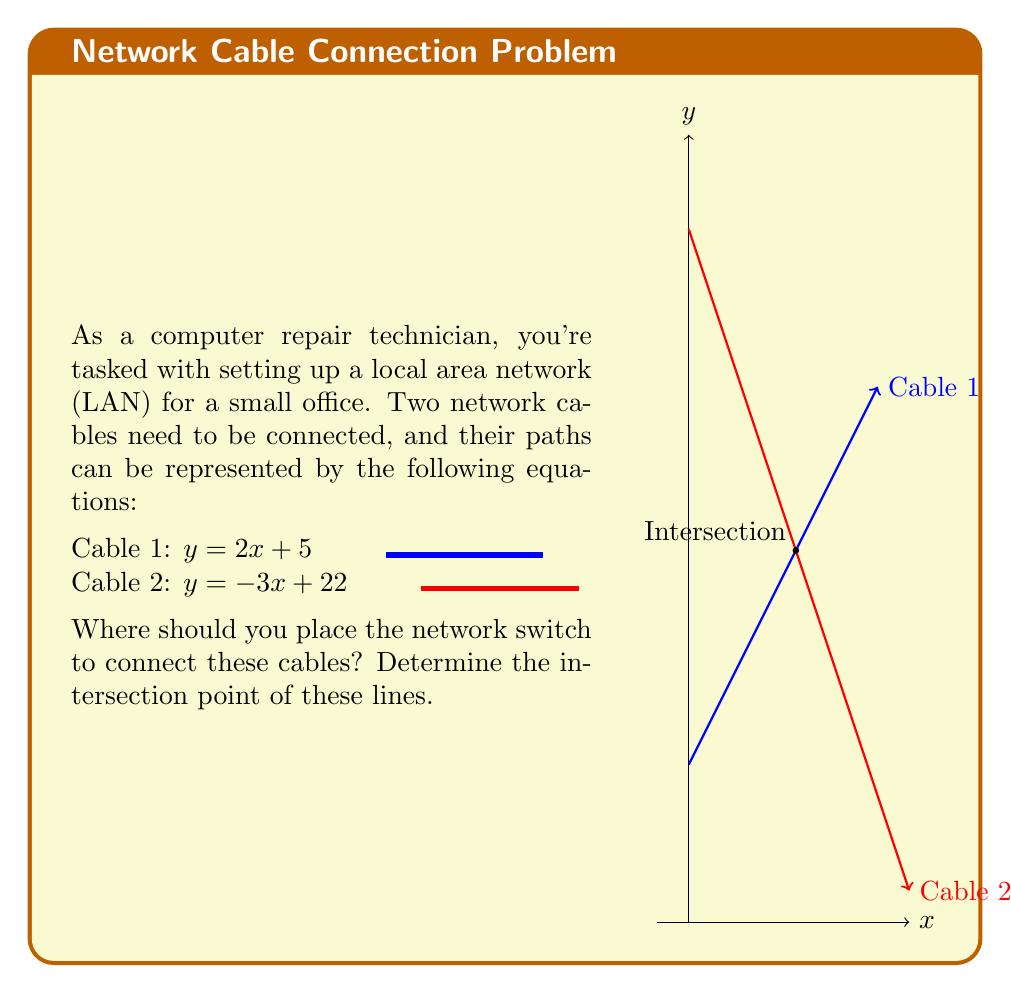Can you solve this math problem? Let's solve this step-by-step:

1) We have two linear equations:
   Cable 1: $y = 2x + 5$
   Cable 2: $y = -3x + 22$

2) At the intersection point, the $x$ and $y$ coordinates will be the same for both equations. So we can set them equal to each other:

   $2x + 5 = -3x + 22$

3) Now, let's solve for $x$:
   $2x + 5 = -3x + 22$
   $2x + 3x = 22 - 5$
   $5x = 17$
   $x = \frac{17}{5} = 3.4$

4) Now that we know $x$, we can substitute it into either of the original equations to find $y$. Let's use Cable 1's equation:

   $y = 2x + 5$
   $y = 2(3.4) + 5$
   $y = 6.8 + 5 = 11.8$

5) Therefore, the intersection point is $(3.4, 11.8)$.

This point represents where you should place the network switch to connect the two cables.
Answer: $(3.4, 11.8)$ 